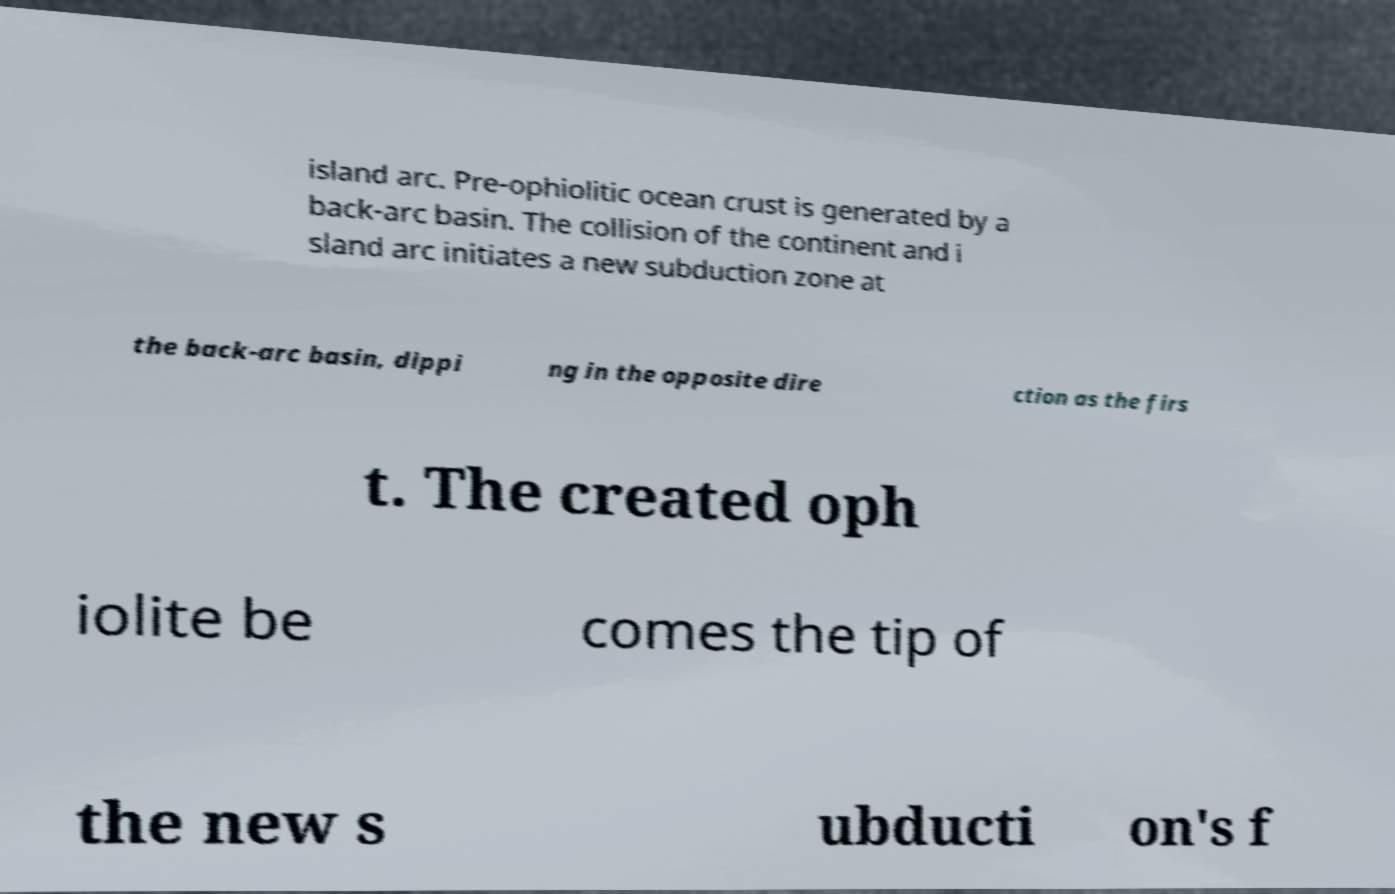There's text embedded in this image that I need extracted. Can you transcribe it verbatim? island arc. Pre-ophiolitic ocean crust is generated by a back-arc basin. The collision of the continent and i sland arc initiates a new subduction zone at the back-arc basin, dippi ng in the opposite dire ction as the firs t. The created oph iolite be comes the tip of the new s ubducti on's f 